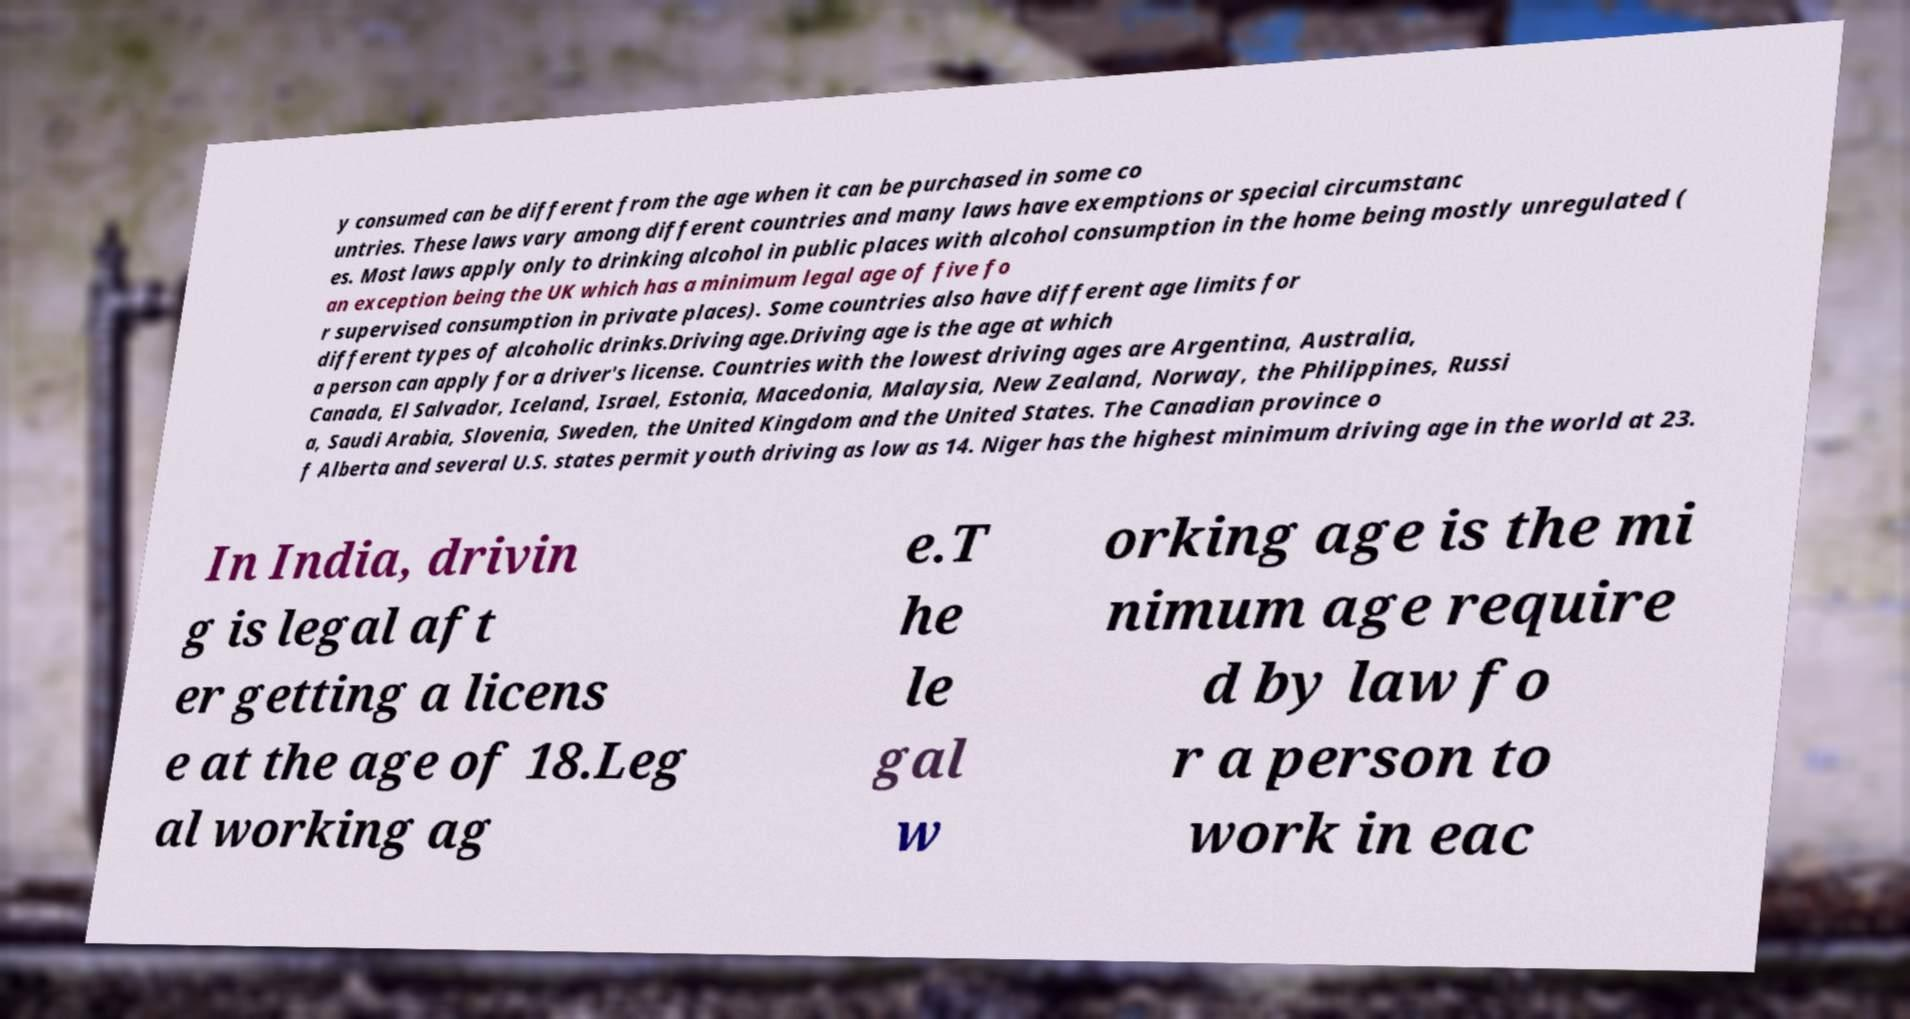Can you accurately transcribe the text from the provided image for me? y consumed can be different from the age when it can be purchased in some co untries. These laws vary among different countries and many laws have exemptions or special circumstanc es. Most laws apply only to drinking alcohol in public places with alcohol consumption in the home being mostly unregulated ( an exception being the UK which has a minimum legal age of five fo r supervised consumption in private places). Some countries also have different age limits for different types of alcoholic drinks.Driving age.Driving age is the age at which a person can apply for a driver's license. Countries with the lowest driving ages are Argentina, Australia, Canada, El Salvador, Iceland, Israel, Estonia, Macedonia, Malaysia, New Zealand, Norway, the Philippines, Russi a, Saudi Arabia, Slovenia, Sweden, the United Kingdom and the United States. The Canadian province o f Alberta and several U.S. states permit youth driving as low as 14. Niger has the highest minimum driving age in the world at 23. In India, drivin g is legal aft er getting a licens e at the age of 18.Leg al working ag e.T he le gal w orking age is the mi nimum age require d by law fo r a person to work in eac 